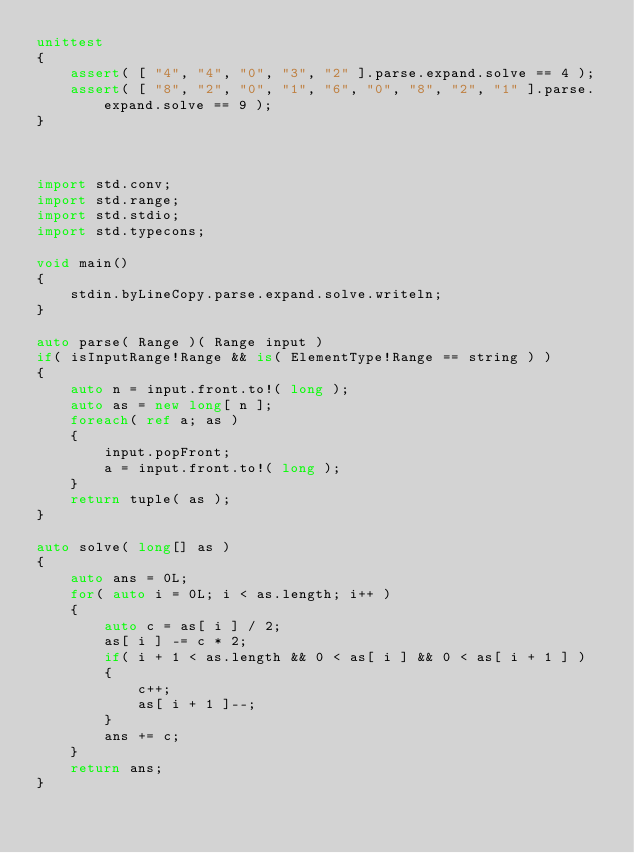<code> <loc_0><loc_0><loc_500><loc_500><_D_>unittest
{
	assert( [ "4", "4", "0", "3", "2" ].parse.expand.solve == 4 );
	assert( [ "8", "2", "0", "1", "6", "0", "8", "2", "1" ].parse.expand.solve == 9 );
}



import std.conv;
import std.range;
import std.stdio;
import std.typecons;

void main()
{
	stdin.byLineCopy.parse.expand.solve.writeln;
}

auto parse( Range )( Range input )
if( isInputRange!Range && is( ElementType!Range == string ) )
{
	auto n = input.front.to!( long );
	auto as = new long[ n ];
	foreach( ref a; as )
	{
		input.popFront;
		a = input.front.to!( long );
	}
	return tuple( as );
}

auto solve( long[] as )
{
	auto ans = 0L;
	for( auto i = 0L; i < as.length; i++ )
	{
		auto c = as[ i ] / 2;
		as[ i ] -= c * 2;
		if( i + 1 < as.length && 0 < as[ i ] && 0 < as[ i + 1 ] )
		{
			c++;
			as[ i + 1 ]--;
		}
		ans += c;
	}
	return ans;
}
</code> 